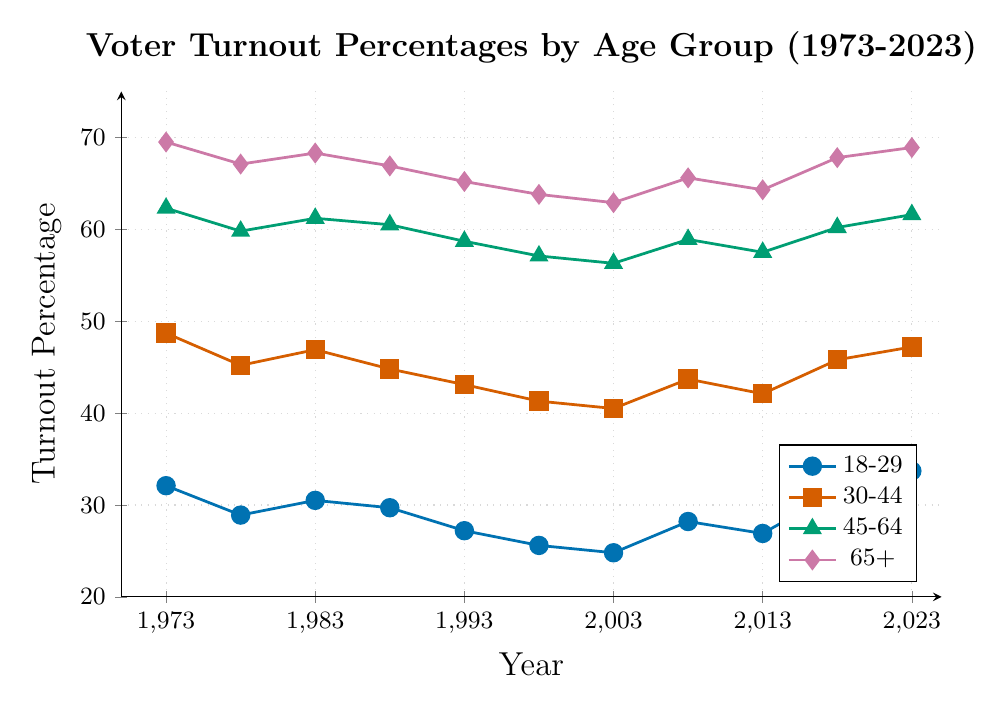What is the voter turnout percentage trend for the 18-29 age group over the 50-year span? The line for the 18-29 age group initially shows a decline from 32.1% in 1973 to a low of 24.8% in 2003, followed by an increase to 33.7% in 2023.
Answer: Initial decline, then increase Which age group had the highest voter turnout in 2023? Referencing the data points for all age groups in 2023, the 65+ group has the highest turnout at 68.9%.
Answer: 65+ How did the voter turnout for the 30-44 age group change from 1973 to 2023? The turnout percentage decreased from 48.7% in 1973 to 40.5% in 2003, then increased to 47.2% in 2023.
Answer: Decreased then increased In which year did the 45-64 age group experience the lowest voter turnout? By looking at each data point for the 45-64 age group, the lowest percentage was in 2003 at 56.3%.
Answer: 2003 Compare the voter turnout percentages for all age groups in 1988. Which group had the lowest and the highest turnout rates? In 1988, the 18-29 age group had the lowest turnout at 29.7%, while the 65+ age group had the highest turnout at 66.9%.
Answer: 18-29 lowest, 65+ highest What is the difference in voter turnout between the 65+ age group and the 18-29 age group in 2023? The turnout percentage for 65+ is 68.9% and for 18-29 is 33.7%. The difference is 68.9% - 33.7% = 35.2%.
Answer: 35.2% Which age group shows the most stability (least change) in voter turnout percentage over the 50 years? Calculating the range (highest - lowest) for each age group: 
18-29 (33.7% - 24.8% = 8.9%), 30-44 (48.7% - 40.5% = 8.2%), 45-64 (62.3% - 56.3% = 6%), 65+ (69.5% - 62.9% = 6.6%). The 45-64 age group has the smallest range.
Answer: 45-64 What was the voter turnout percentage for the 18-29 age group in the year 2008? The data point for the 18-29 age group in 2008 is indicated as 28.2%.
Answer: 28.2% By how much did the voter turnout percentage for the 30-44 age group decrease between 1973 and 1998? The voter turnout in 1973 was 48.7% and in 1998 it was 41.3%. The decrease is 48.7% - 41.3% = 7.4%.
Answer: 7.4% Which two age groups had the closest voter turnout percentages in 2018? In 2018, the turnout percentages are: 18-29 (31.5%), 30-44 (45.8%), 45-64 (60.2%), 65+ (67.8%). The 30-44 and 45-64 age groups have the closest values, differing by 14.4%.
Answer: 30-44 and 45-64 